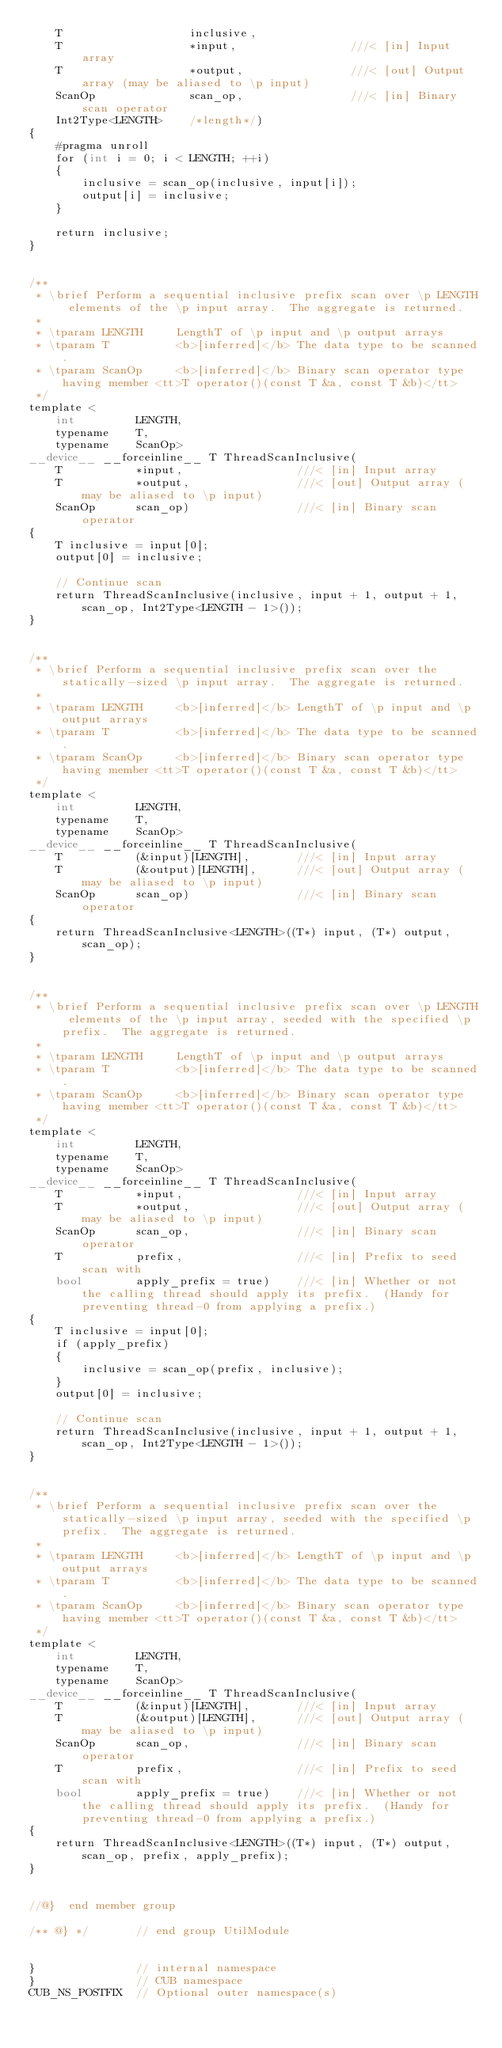<code> <loc_0><loc_0><loc_500><loc_500><_Cuda_>    T                   inclusive,
    T                   *input,                 ///< [in] Input array
    T                   *output,                ///< [out] Output array (may be aliased to \p input)
    ScanOp              scan_op,                ///< [in] Binary scan operator
    Int2Type<LENGTH>    /*length*/)
{
    #pragma unroll
    for (int i = 0; i < LENGTH; ++i)
    {
        inclusive = scan_op(inclusive, input[i]);
        output[i] = inclusive;
    }

    return inclusive;
}


/**
 * \brief Perform a sequential inclusive prefix scan over \p LENGTH elements of the \p input array.  The aggregate is returned.
 *
 * \tparam LENGTH     LengthT of \p input and \p output arrays
 * \tparam T          <b>[inferred]</b> The data type to be scanned.
 * \tparam ScanOp     <b>[inferred]</b> Binary scan operator type having member <tt>T operator()(const T &a, const T &b)</tt>
 */
template <
    int         LENGTH,
    typename    T,
    typename    ScanOp>
__device__ __forceinline__ T ThreadScanInclusive(
    T           *input,                 ///< [in] Input array
    T           *output,                ///< [out] Output array (may be aliased to \p input)
    ScanOp      scan_op)                ///< [in] Binary scan operator
{
    T inclusive = input[0];
    output[0] = inclusive;

    // Continue scan
    return ThreadScanInclusive(inclusive, input + 1, output + 1, scan_op, Int2Type<LENGTH - 1>());
}


/**
 * \brief Perform a sequential inclusive prefix scan over the statically-sized \p input array.  The aggregate is returned.
 *
 * \tparam LENGTH     <b>[inferred]</b> LengthT of \p input and \p output arrays
 * \tparam T          <b>[inferred]</b> The data type to be scanned.
 * \tparam ScanOp     <b>[inferred]</b> Binary scan operator type having member <tt>T operator()(const T &a, const T &b)</tt>
 */
template <
    int         LENGTH,
    typename    T,
    typename    ScanOp>
__device__ __forceinline__ T ThreadScanInclusive(
    T           (&input)[LENGTH],       ///< [in] Input array
    T           (&output)[LENGTH],      ///< [out] Output array (may be aliased to \p input)
    ScanOp      scan_op)                ///< [in] Binary scan operator
{
    return ThreadScanInclusive<LENGTH>((T*) input, (T*) output, scan_op);
}


/**
 * \brief Perform a sequential inclusive prefix scan over \p LENGTH elements of the \p input array, seeded with the specified \p prefix.  The aggregate is returned.
 *
 * \tparam LENGTH     LengthT of \p input and \p output arrays
 * \tparam T          <b>[inferred]</b> The data type to be scanned.
 * \tparam ScanOp     <b>[inferred]</b> Binary scan operator type having member <tt>T operator()(const T &a, const T &b)</tt>
 */
template <
    int         LENGTH,
    typename    T,
    typename    ScanOp>
__device__ __forceinline__ T ThreadScanInclusive(
    T           *input,                 ///< [in] Input array
    T           *output,                ///< [out] Output array (may be aliased to \p input)
    ScanOp      scan_op,                ///< [in] Binary scan operator
    T           prefix,                 ///< [in] Prefix to seed scan with
    bool        apply_prefix = true)    ///< [in] Whether or not the calling thread should apply its prefix.  (Handy for preventing thread-0 from applying a prefix.)
{
    T inclusive = input[0];
    if (apply_prefix)
    {
        inclusive = scan_op(prefix, inclusive);
    }
    output[0] = inclusive;

    // Continue scan
    return ThreadScanInclusive(inclusive, input + 1, output + 1, scan_op, Int2Type<LENGTH - 1>());
}


/**
 * \brief Perform a sequential inclusive prefix scan over the statically-sized \p input array, seeded with the specified \p prefix.  The aggregate is returned.
 *
 * \tparam LENGTH     <b>[inferred]</b> LengthT of \p input and \p output arrays
 * \tparam T          <b>[inferred]</b> The data type to be scanned.
 * \tparam ScanOp     <b>[inferred]</b> Binary scan operator type having member <tt>T operator()(const T &a, const T &b)</tt>
 */
template <
    int         LENGTH,
    typename    T,
    typename    ScanOp>
__device__ __forceinline__ T ThreadScanInclusive(
    T           (&input)[LENGTH],       ///< [in] Input array
    T           (&output)[LENGTH],      ///< [out] Output array (may be aliased to \p input)
    ScanOp      scan_op,                ///< [in] Binary scan operator
    T           prefix,                 ///< [in] Prefix to seed scan with
    bool        apply_prefix = true)    ///< [in] Whether or not the calling thread should apply its prefix.  (Handy for preventing thread-0 from applying a prefix.)
{
    return ThreadScanInclusive<LENGTH>((T*) input, (T*) output, scan_op, prefix, apply_prefix);
}


//@}  end member group

/** @} */       // end group UtilModule


}               // internal namespace
}               // CUB namespace
CUB_NS_POSTFIX  // Optional outer namespace(s)
</code> 